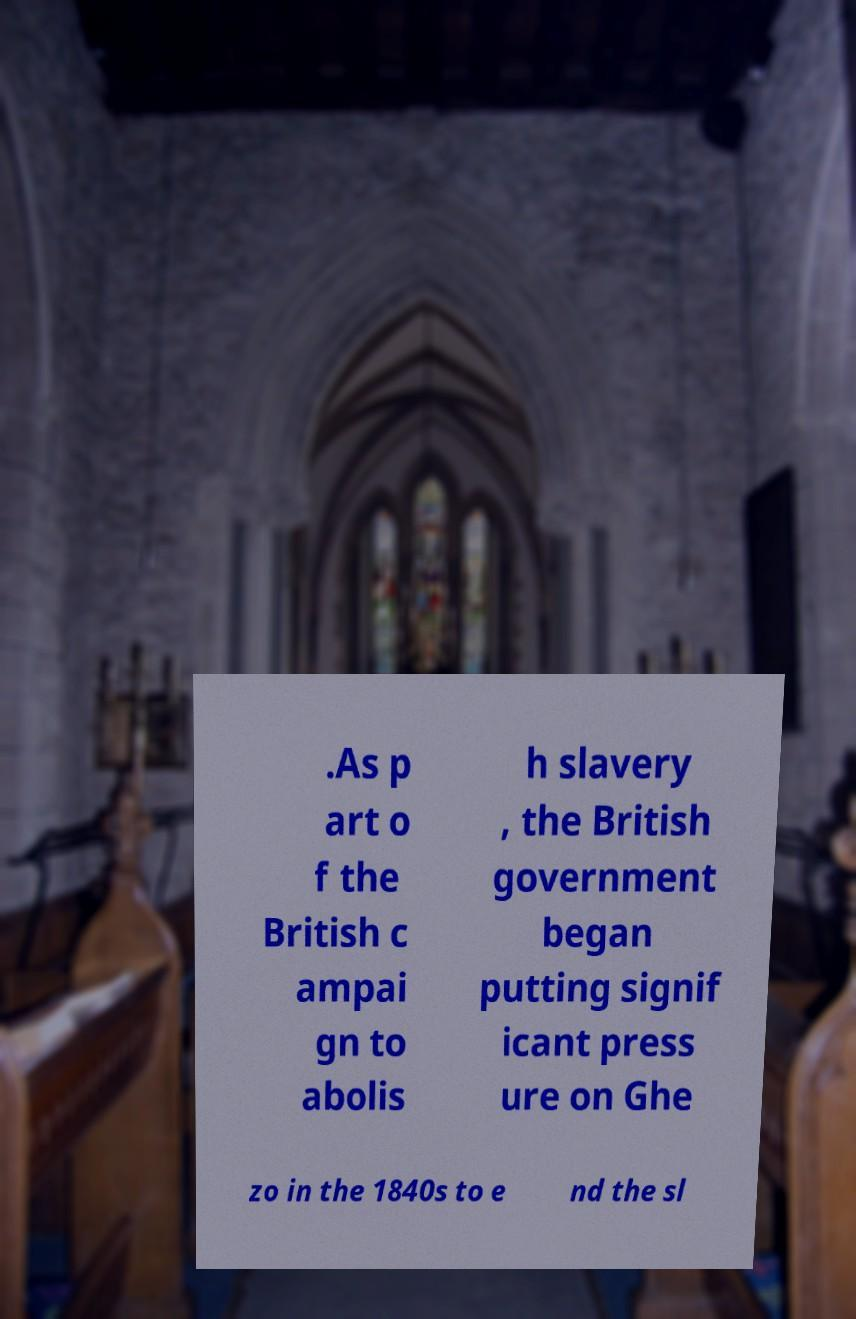Please identify and transcribe the text found in this image. .As p art o f the British c ampai gn to abolis h slavery , the British government began putting signif icant press ure on Ghe zo in the 1840s to e nd the sl 